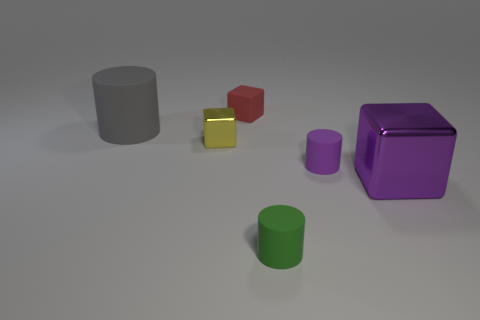Subtract all tiny cylinders. How many cylinders are left? 1 Add 3 small yellow metallic objects. How many objects exist? 9 Subtract 1 cylinders. How many cylinders are left? 2 Subtract all gray rubber blocks. Subtract all purple matte cylinders. How many objects are left? 5 Add 1 purple metallic cubes. How many purple metallic cubes are left? 2 Add 6 large purple metallic cubes. How many large purple metallic cubes exist? 7 Subtract 0 green blocks. How many objects are left? 6 Subtract all cyan cubes. Subtract all green balls. How many cubes are left? 3 